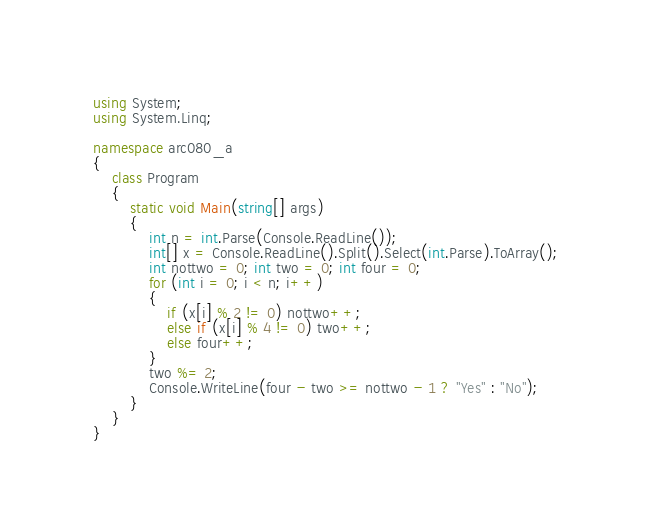Convert code to text. <code><loc_0><loc_0><loc_500><loc_500><_C#_>using System;
using System.Linq;

namespace arc080_a
{
    class Program
    {
        static void Main(string[] args)
        {
            int n = int.Parse(Console.ReadLine());
            int[] x = Console.ReadLine().Split().Select(int.Parse).ToArray();
            int nottwo = 0; int two = 0; int four = 0;
            for (int i = 0; i < n; i++)
            {
                if (x[i] % 2 != 0) nottwo++;
                else if (x[i] % 4 != 0) two++;
                else four++;
            }
            two %= 2;
            Console.WriteLine(four - two >= nottwo - 1 ? "Yes" : "No");
        }
    }
}</code> 